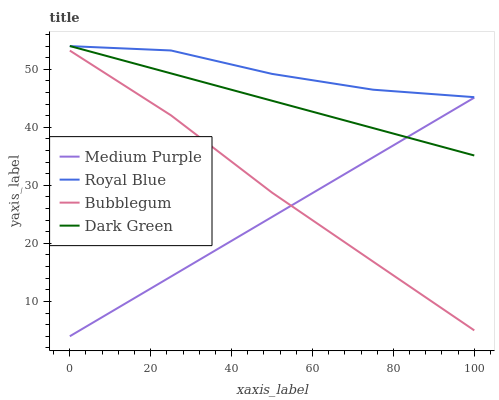Does Medium Purple have the minimum area under the curve?
Answer yes or no. Yes. Does Royal Blue have the maximum area under the curve?
Answer yes or no. Yes. Does Bubblegum have the minimum area under the curve?
Answer yes or no. No. Does Bubblegum have the maximum area under the curve?
Answer yes or no. No. Is Medium Purple the smoothest?
Answer yes or no. Yes. Is Royal Blue the roughest?
Answer yes or no. Yes. Is Bubblegum the smoothest?
Answer yes or no. No. Is Bubblegum the roughest?
Answer yes or no. No. Does Medium Purple have the lowest value?
Answer yes or no. Yes. Does Bubblegum have the lowest value?
Answer yes or no. No. Does Dark Green have the highest value?
Answer yes or no. Yes. Does Royal Blue have the highest value?
Answer yes or no. No. Is Bubblegum less than Dark Green?
Answer yes or no. Yes. Is Dark Green greater than Bubblegum?
Answer yes or no. Yes. Does Medium Purple intersect Dark Green?
Answer yes or no. Yes. Is Medium Purple less than Dark Green?
Answer yes or no. No. Is Medium Purple greater than Dark Green?
Answer yes or no. No. Does Bubblegum intersect Dark Green?
Answer yes or no. No. 